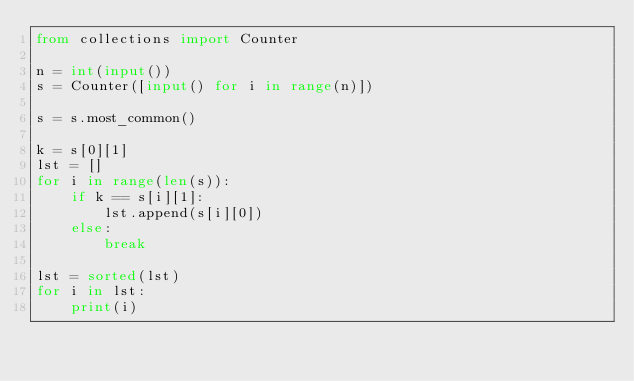<code> <loc_0><loc_0><loc_500><loc_500><_Python_>from collections import Counter

n = int(input())
s = Counter([input() for i in range(n)])

s = s.most_common()

k = s[0][1]
lst = []
for i in range(len(s)):
    if k == s[i][1]:
        lst.append(s[i][0])
    else:
        break

lst = sorted(lst)
for i in lst:
    print(i)
</code> 